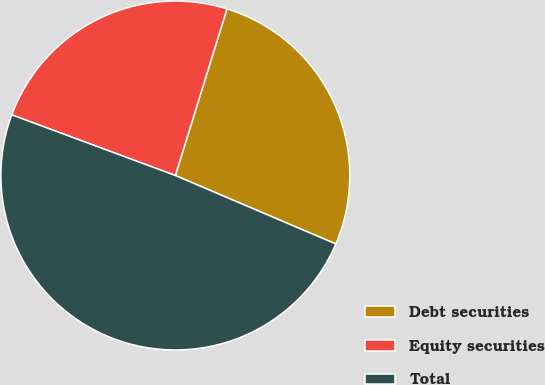Convert chart to OTSL. <chart><loc_0><loc_0><loc_500><loc_500><pie_chart><fcel>Debt securities<fcel>Equity securities<fcel>Total<nl><fcel>26.64%<fcel>24.13%<fcel>49.24%<nl></chart> 